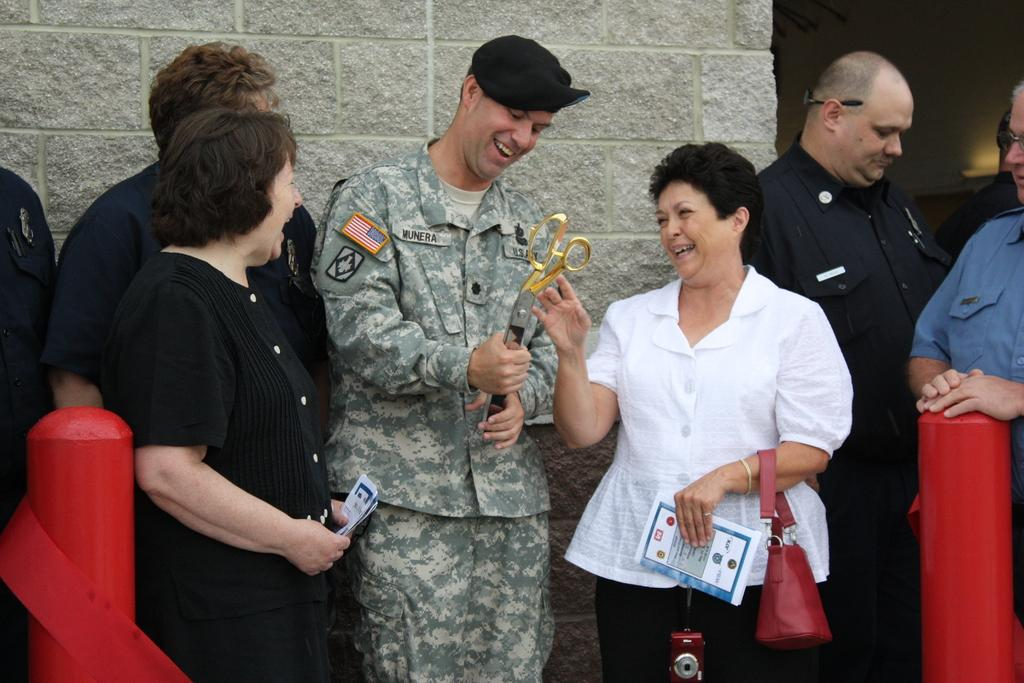What is happening in the center of the image? There are people standing in the center of the image. What can be seen in the background of the image? There is a wall in the background of the image. How many pies are being used as an example in the image? There are no pies present in the image. What sound can be heard from the bells in the image? There are no bells present in the image. 